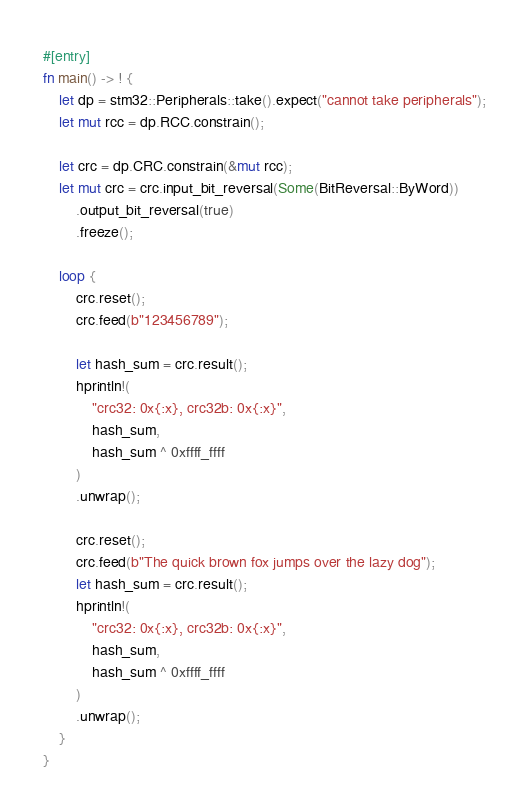Convert code to text. <code><loc_0><loc_0><loc_500><loc_500><_Rust_>#[entry]
fn main() -> ! {
    let dp = stm32::Peripherals::take().expect("cannot take peripherals");
    let mut rcc = dp.RCC.constrain();

    let crc = dp.CRC.constrain(&mut rcc);
    let mut crc = crc.input_bit_reversal(Some(BitReversal::ByWord))
        .output_bit_reversal(true)
        .freeze();

    loop {
        crc.reset();
        crc.feed(b"123456789");

        let hash_sum = crc.result();
        hprintln!(
            "crc32: 0x{:x}, crc32b: 0x{:x}",
            hash_sum,
            hash_sum ^ 0xffff_ffff
        )
        .unwrap();

        crc.reset();
        crc.feed(b"The quick brown fox jumps over the lazy dog");
        let hash_sum = crc.result();
        hprintln!(
            "crc32: 0x{:x}, crc32b: 0x{:x}",
            hash_sum,
            hash_sum ^ 0xffff_ffff
        )
        .unwrap();
    }
}
</code> 